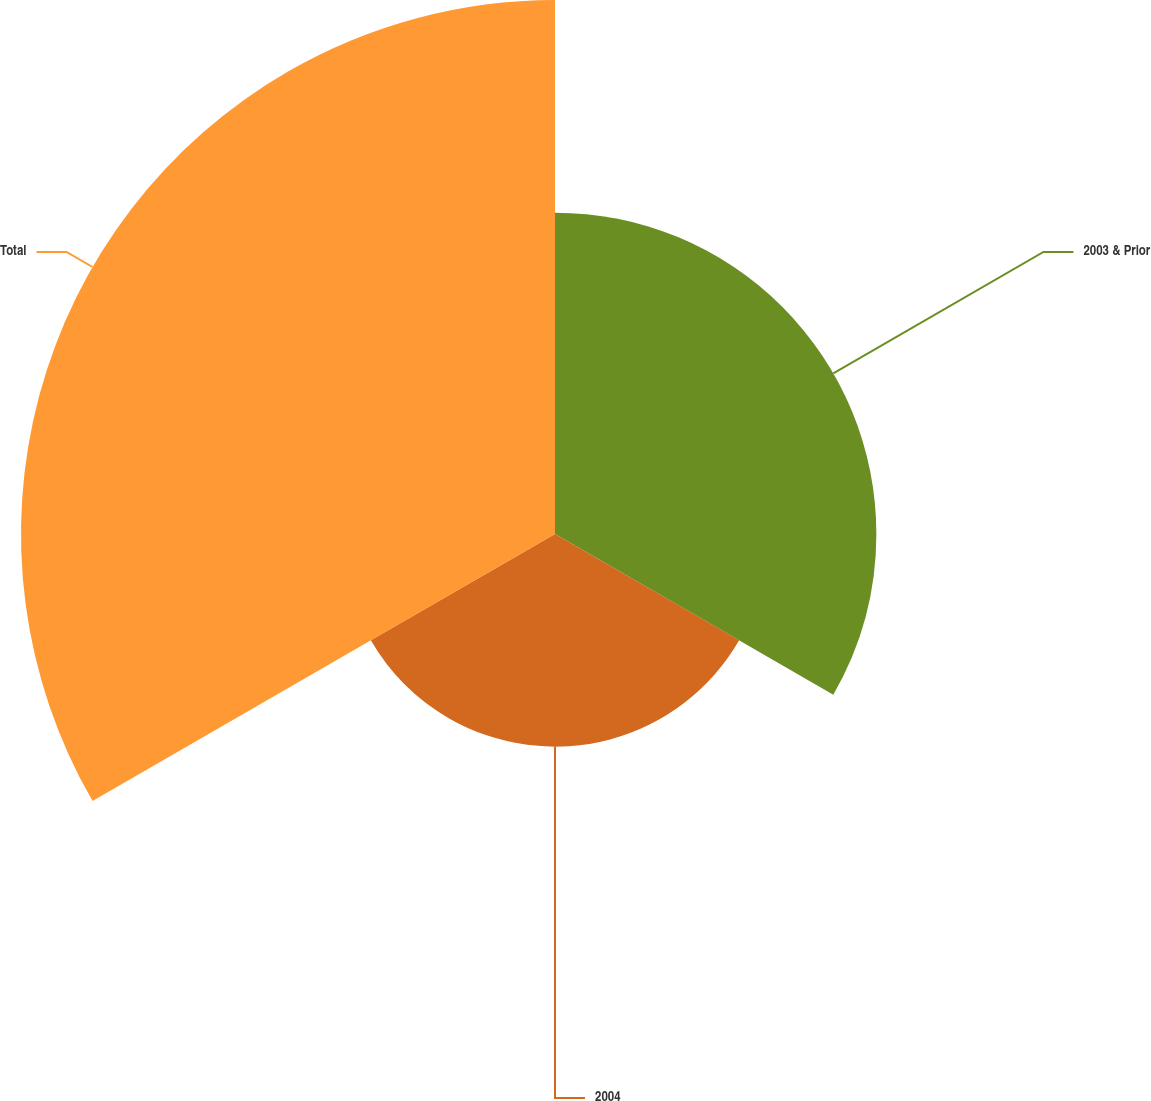Convert chart to OTSL. <chart><loc_0><loc_0><loc_500><loc_500><pie_chart><fcel>2003 & Prior<fcel>2004<fcel>Total<nl><fcel>30.09%<fcel>19.91%<fcel>50.0%<nl></chart> 